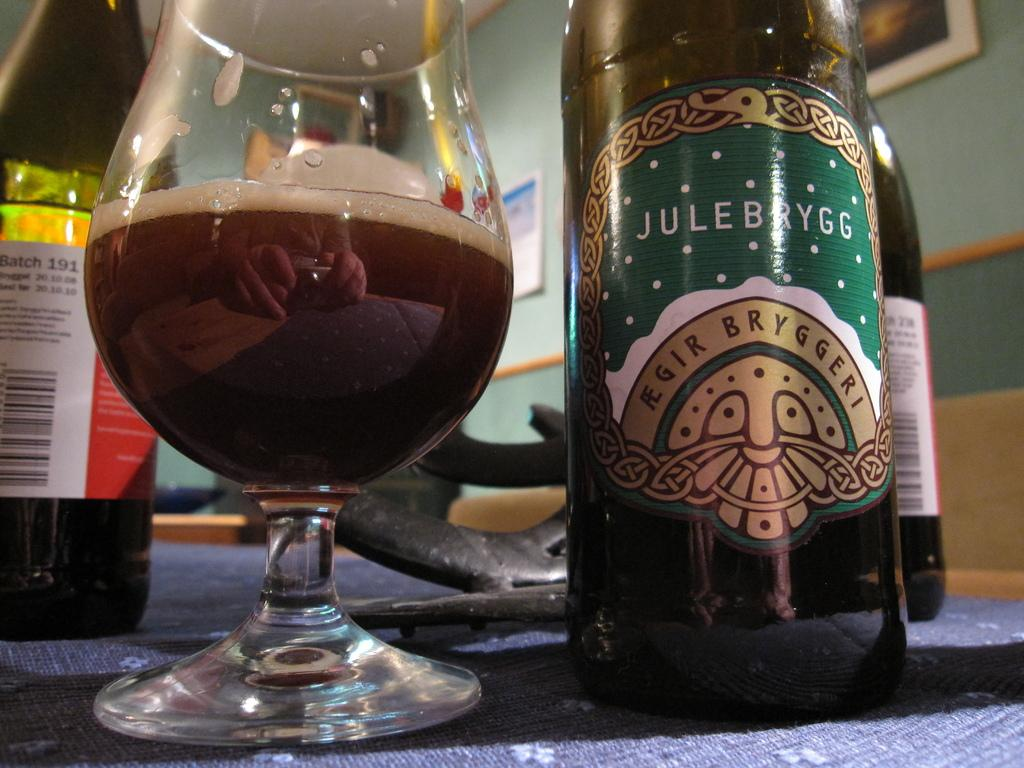What type of containers are visible in the image? There are bottles in the image. What other type of container can be seen in the image? There is a glass in the image. What is present on the wall in the background of the image? There are frames attached to the wall in the background of the image. How many fingers are visible in the image? There are no fingers visible in the image. What type of tax is being discussed in the image? There is no discussion of tax in the image. 